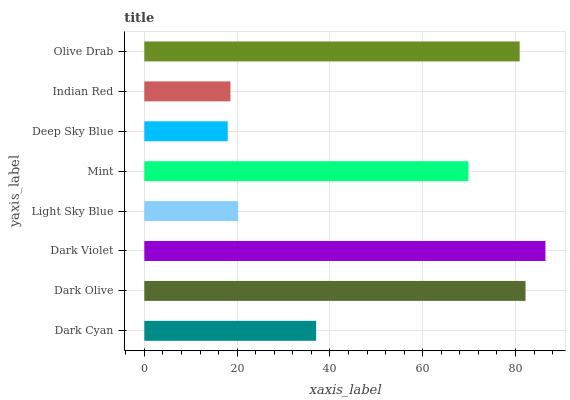Is Deep Sky Blue the minimum?
Answer yes or no. Yes. Is Dark Violet the maximum?
Answer yes or no. Yes. Is Dark Olive the minimum?
Answer yes or no. No. Is Dark Olive the maximum?
Answer yes or no. No. Is Dark Olive greater than Dark Cyan?
Answer yes or no. Yes. Is Dark Cyan less than Dark Olive?
Answer yes or no. Yes. Is Dark Cyan greater than Dark Olive?
Answer yes or no. No. Is Dark Olive less than Dark Cyan?
Answer yes or no. No. Is Mint the high median?
Answer yes or no. Yes. Is Dark Cyan the low median?
Answer yes or no. Yes. Is Olive Drab the high median?
Answer yes or no. No. Is Light Sky Blue the low median?
Answer yes or no. No. 